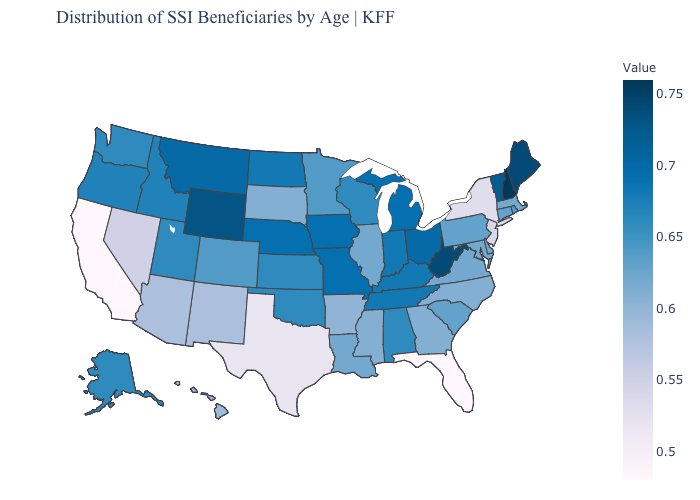Among the states that border Oregon , does California have the lowest value?
Short answer required. Yes. Among the states that border Arizona , does Utah have the highest value?
Give a very brief answer. Yes. Which states have the highest value in the USA?
Answer briefly. New Hampshire. Which states have the lowest value in the South?
Quick response, please. Florida. Among the states that border Colorado , which have the highest value?
Be succinct. Wyoming. Which states have the highest value in the USA?
Concise answer only. New Hampshire. 